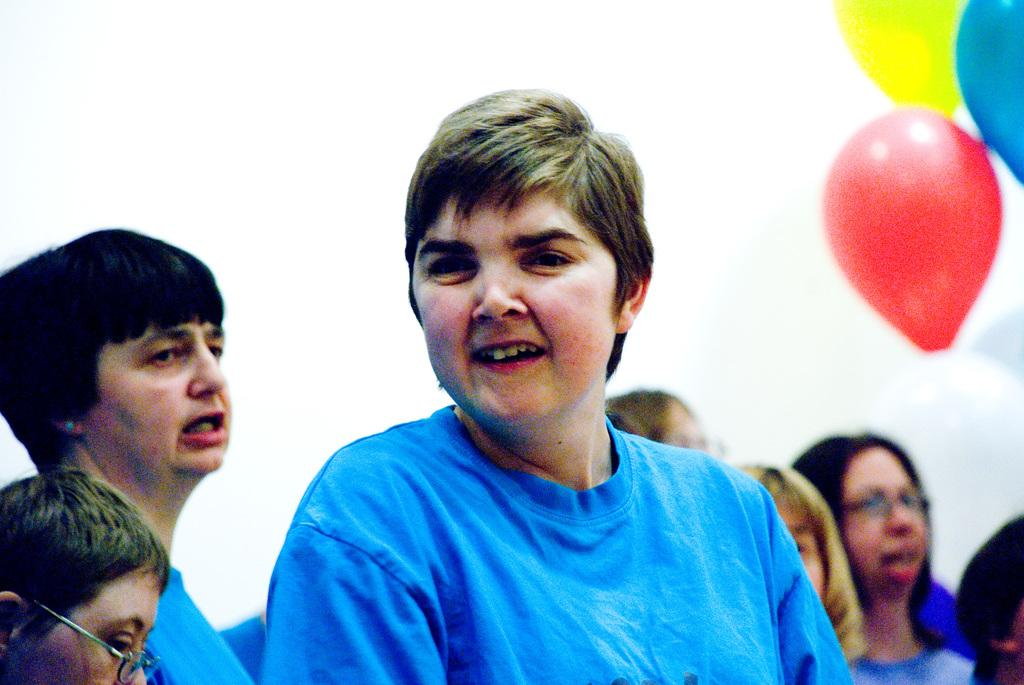How many people are in the image? There are persons in the image, but the exact number cannot be determined from the provided facts. What is the background of the image? There is a wall in the image, which serves as the background. What decorative elements can be seen in the image? Balloons are present in the image, which may be used for decoration or celebration. What type of beast is singing a song in the image? There is no beast or song present in the image; it features persons and a wall. 